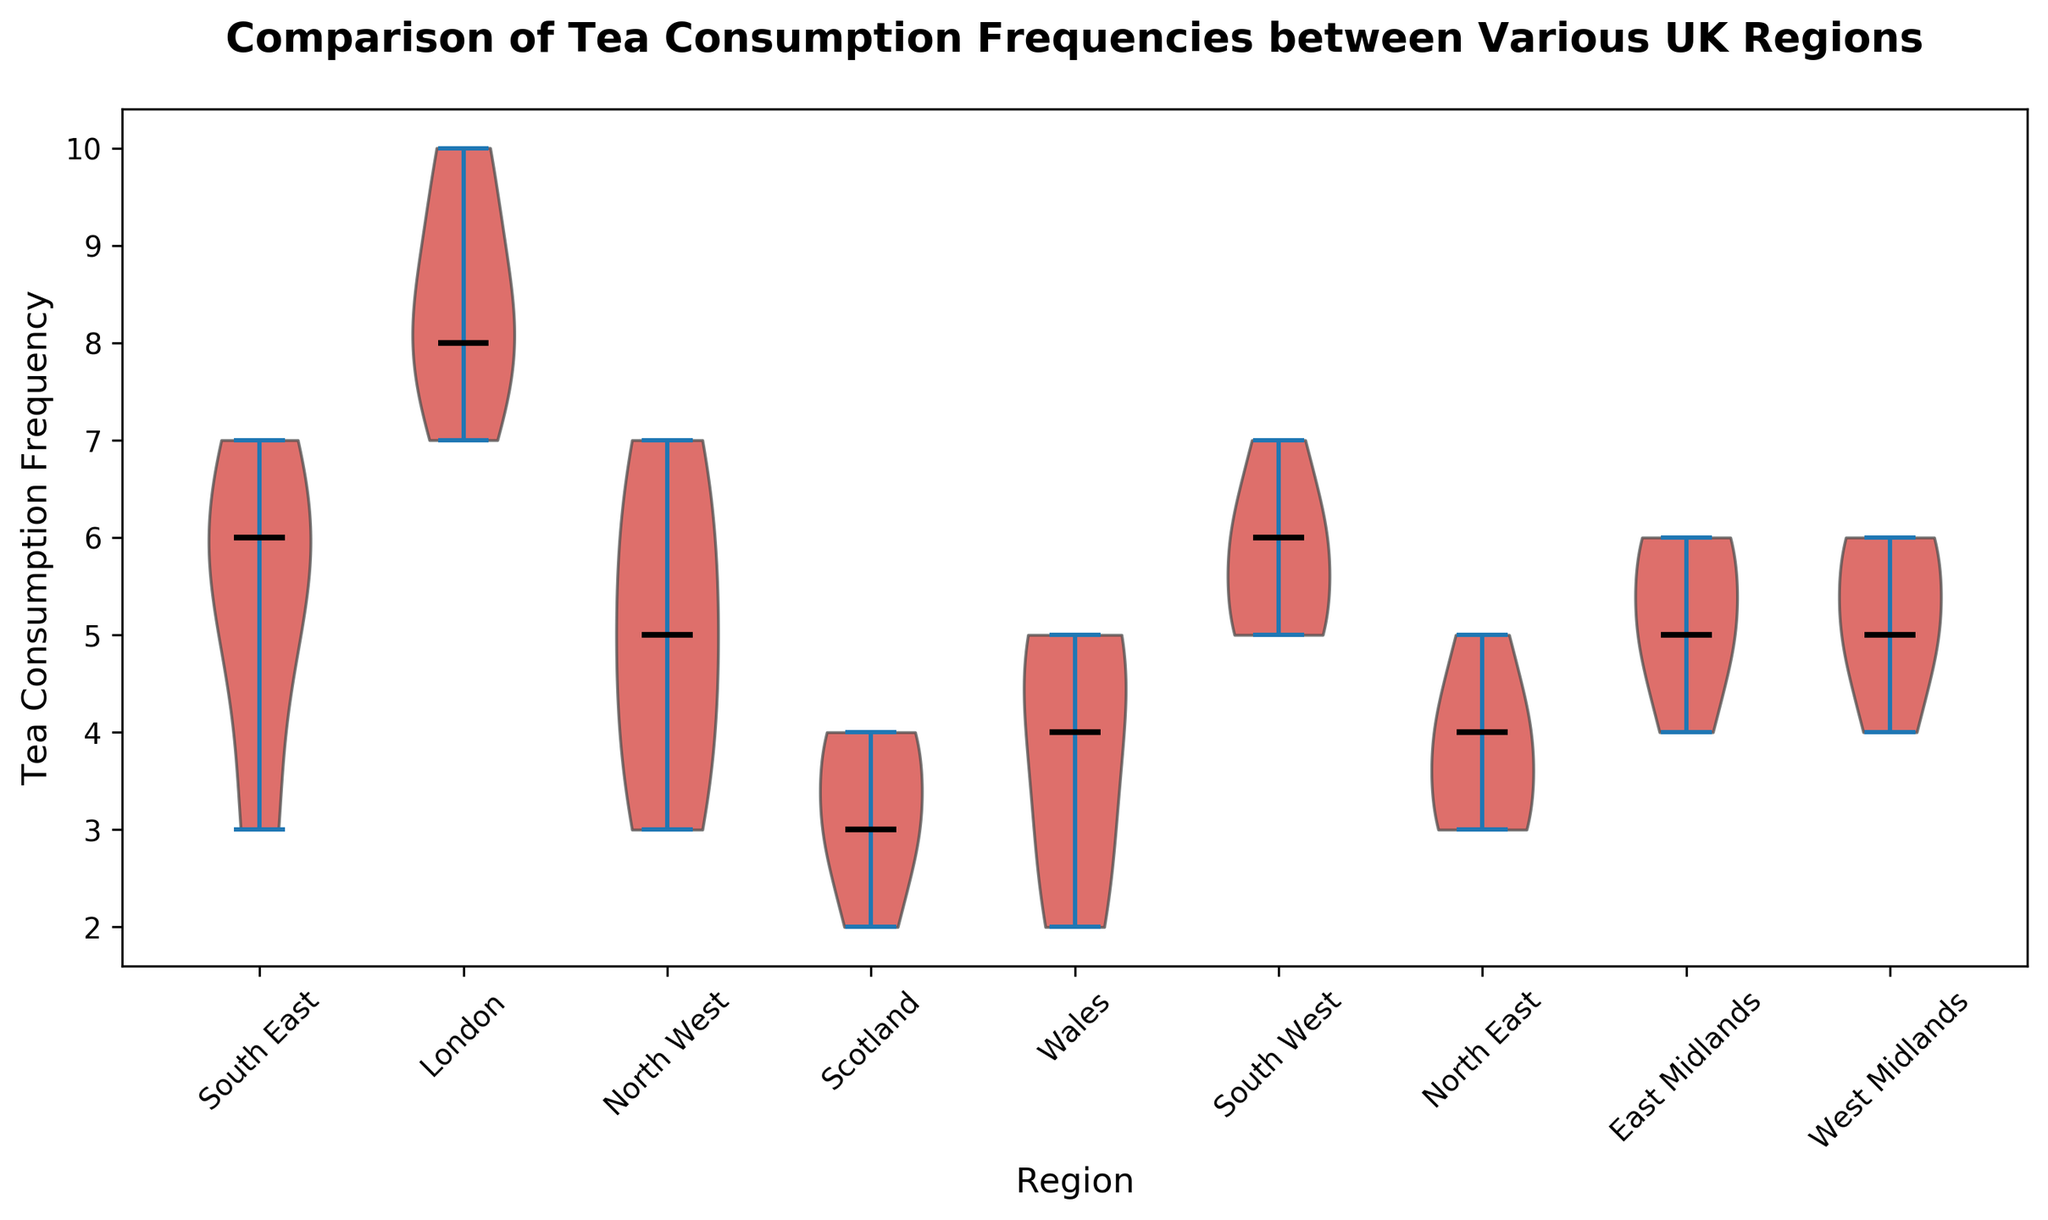Which region has the highest median tea consumption frequency? To find the region with the highest median tea consumption frequency, one examines the black line (median marker) in each violin plot. The highest median marker is in the London region.
Answer: London Which region has the lowest median tea consumption frequency, and what is that number? Examine the black median markers in the violin plots. The lowest median is for the Scotland region, showing a median frequency of tea consumption of 3.
Answer: Scotland, 3 How does the median tea consumption frequency in the South East compare to that in Wales? Examine the black median markers in the violin plots for the South East and Wales regions. Both show identical median values of 6 and 4, respectively.
Answer: South East 6, Wales 4 Which regions have a median tea consumption frequency of 5 or higher? By examining the black median lines, the regions with medians of 5 or higher are South East, London, South West, West Midlands, and East Midlands.
Answer: SE, LND, SW, WM, EM What is the range (max-min) of tea consumption frequency in the North West region? The range is calculated by subtracting the lowest value in the North West's violin plot from the highest value. Thus, it's 7 - 3 = 4.
Answer: 4 Which region has the widest spread of tea consumption frequencies? The spread can be noticed by looking at the overall shape and length of the violin plots. London has the widest spread as its plot spans from 7 to 10 with slight spread.
Answer: London How many regions have exactly the same median tea consumption frequency? The regions with the same median can be identified by comparing the black median lines. South East and South West both have median values of 5.
Answer: 2 Which violin plot is the tallest, and what does it indicate about tea consumption in that region? The tallest violin plot is London’s, indicating it spans the widest range of tea consumption frequencies. It indicates a varied frequency of tea consumption in London.
Answer: London, varied frequency Which region exhibits the smallest spread in its tea consumption frequencies? Scotland's violin plot has the smallest spread as it spans from 2 to 4 with a median of 3.
Answer: Scotland In which region(s) does the tea consumption frequency predominantly lean towards higher values? The violin plot for London shows a clear skew towards higher values, with most data points between 7 and 10.
Answer: London 